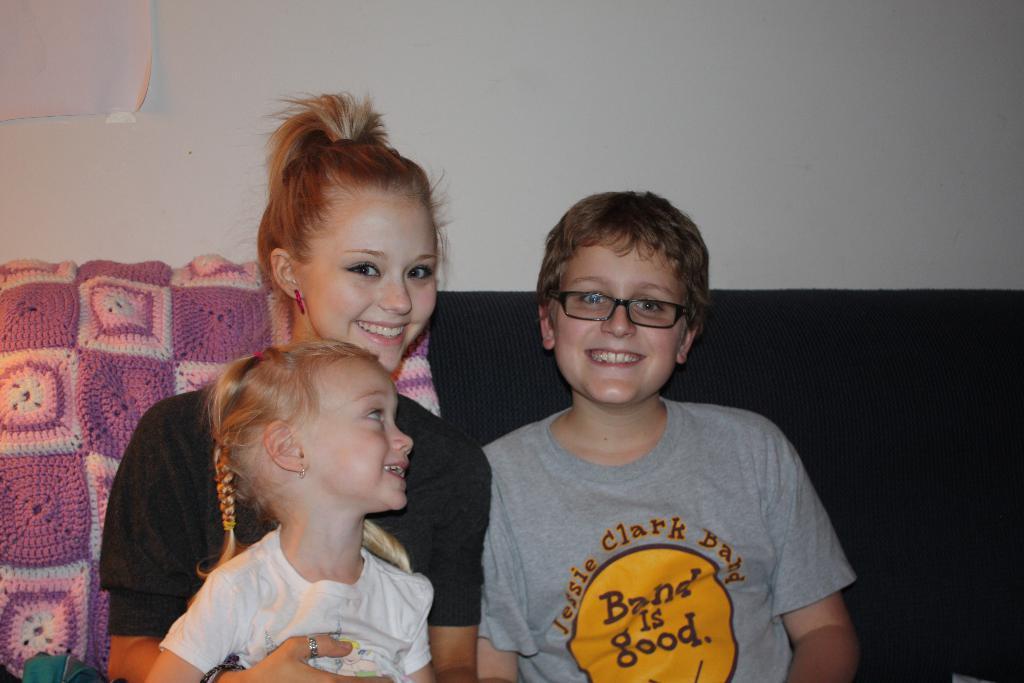Can you describe this image briefly? In this image we can see three people on the couch, there is a cloth on it, also we can see the white color wall. 